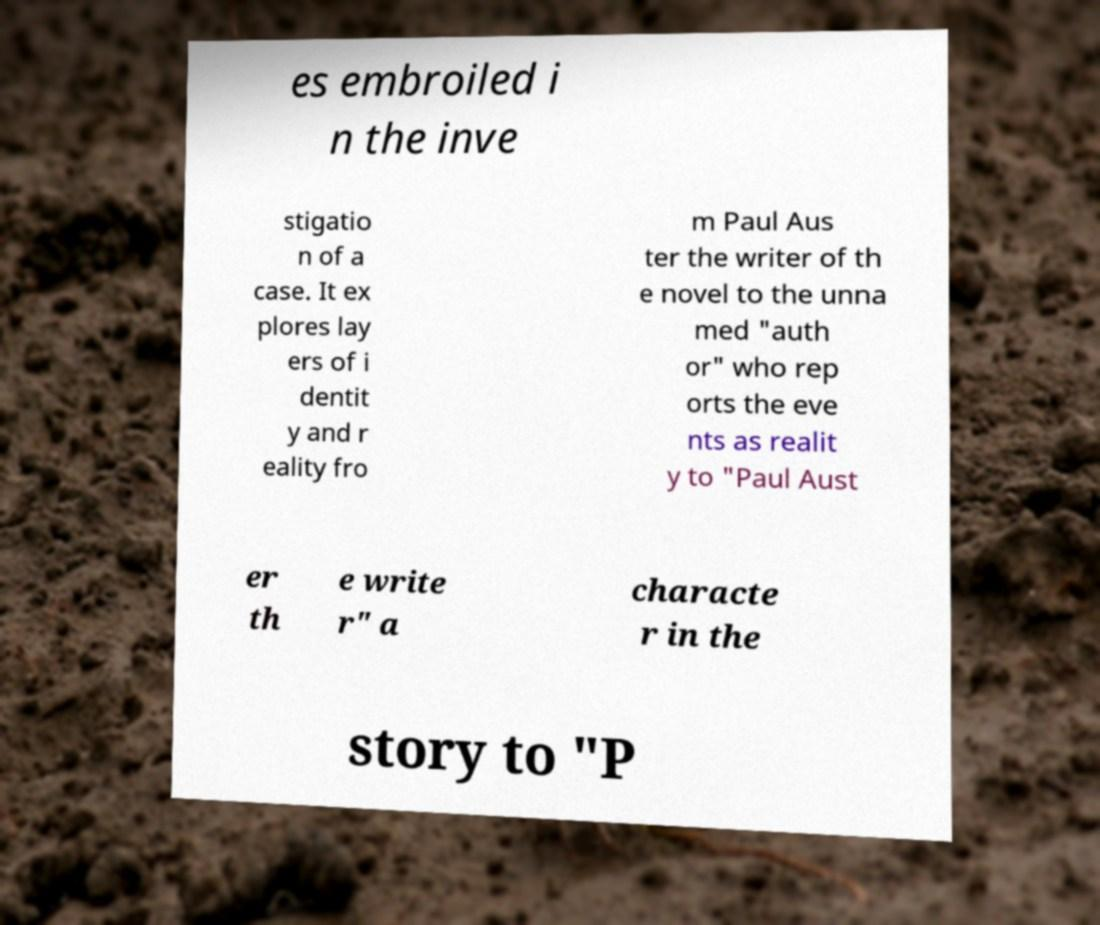For documentation purposes, I need the text within this image transcribed. Could you provide that? es embroiled i n the inve stigatio n of a case. It ex plores lay ers of i dentit y and r eality fro m Paul Aus ter the writer of th e novel to the unna med "auth or" who rep orts the eve nts as realit y to "Paul Aust er th e write r" a characte r in the story to "P 